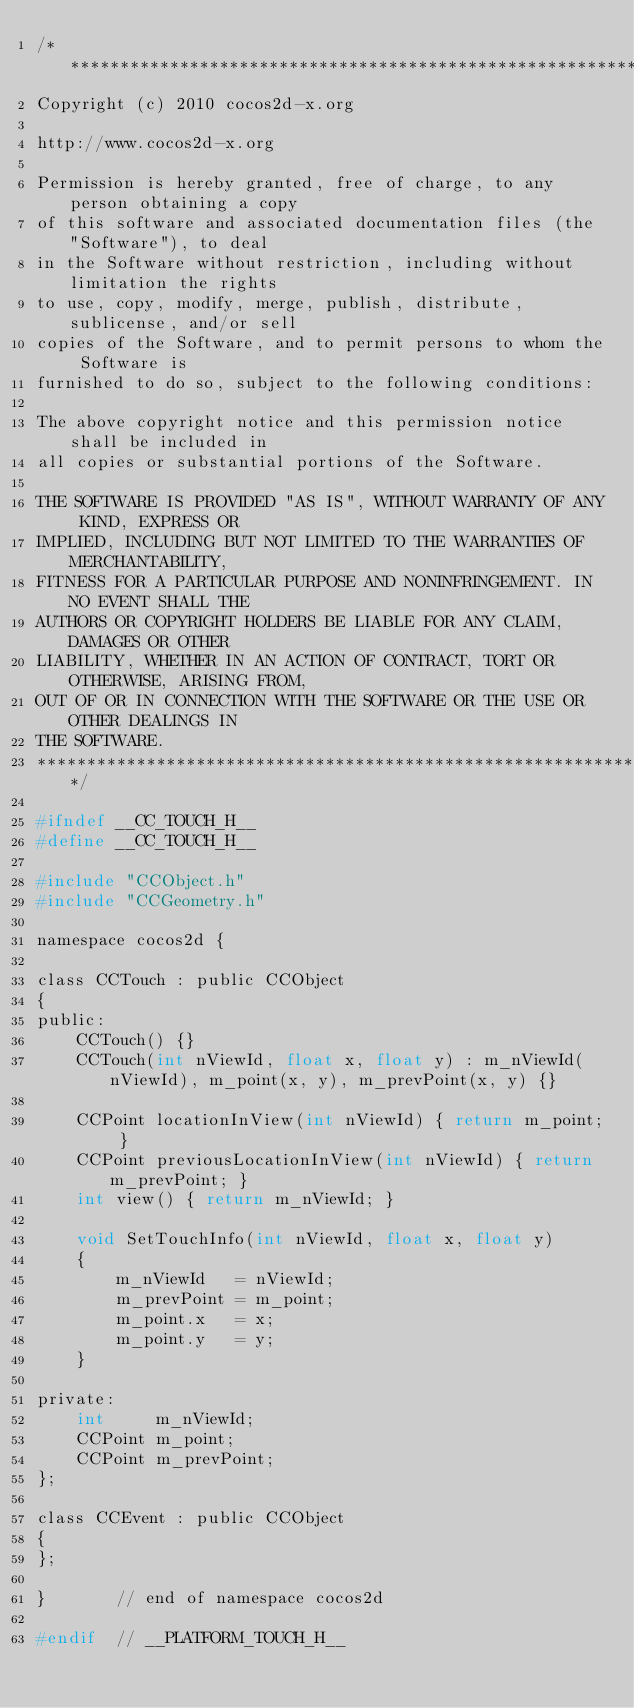Convert code to text. <code><loc_0><loc_0><loc_500><loc_500><_C_>/****************************************************************************
Copyright (c) 2010 cocos2d-x.org

http://www.cocos2d-x.org

Permission is hereby granted, free of charge, to any person obtaining a copy
of this software and associated documentation files (the "Software"), to deal
in the Software without restriction, including without limitation the rights
to use, copy, modify, merge, publish, distribute, sublicense, and/or sell
copies of the Software, and to permit persons to whom the Software is
furnished to do so, subject to the following conditions:

The above copyright notice and this permission notice shall be included in
all copies or substantial portions of the Software.

THE SOFTWARE IS PROVIDED "AS IS", WITHOUT WARRANTY OF ANY KIND, EXPRESS OR
IMPLIED, INCLUDING BUT NOT LIMITED TO THE WARRANTIES OF MERCHANTABILITY,
FITNESS FOR A PARTICULAR PURPOSE AND NONINFRINGEMENT. IN NO EVENT SHALL THE
AUTHORS OR COPYRIGHT HOLDERS BE LIABLE FOR ANY CLAIM, DAMAGES OR OTHER
LIABILITY, WHETHER IN AN ACTION OF CONTRACT, TORT OR OTHERWISE, ARISING FROM,
OUT OF OR IN CONNECTION WITH THE SOFTWARE OR THE USE OR OTHER DEALINGS IN
THE SOFTWARE.
****************************************************************************/

#ifndef __CC_TOUCH_H__
#define __CC_TOUCH_H__

#include "CCObject.h"
#include "CCGeometry.h"

namespace cocos2d {

class CCTouch : public CCObject
{
public:
    CCTouch() {}
    CCTouch(int nViewId, float x, float y) : m_nViewId(nViewId), m_point(x, y), m_prevPoint(x, y) {}

    CCPoint locationInView(int nViewId) { return m_point; }
    CCPoint previousLocationInView(int nViewId) { return m_prevPoint; }
    int view() { return m_nViewId; }

    void SetTouchInfo(int nViewId, float x, float y)
    {
        m_nViewId   = nViewId;
        m_prevPoint = m_point;
        m_point.x   = x;
        m_point.y   = y;
    }

private:
    int     m_nViewId;
    CCPoint m_point;
    CCPoint	m_prevPoint;
};

class CCEvent : public CCObject
{
};

}       // end of namespace cocos2d

#endif  // __PLATFORM_TOUCH_H__
</code> 